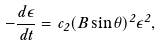<formula> <loc_0><loc_0><loc_500><loc_500>- \frac { d \epsilon } { d t } = c _ { 2 } ( B \sin \theta ) ^ { 2 } \epsilon ^ { 2 } ,</formula> 